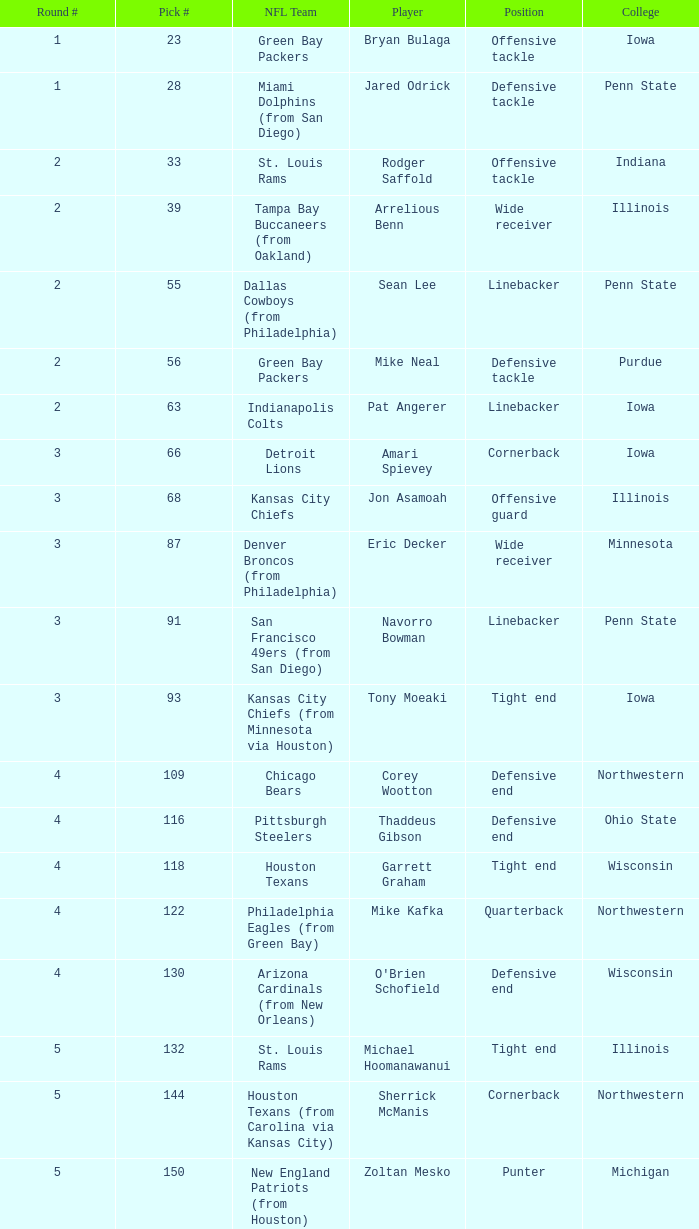What was sherrick mcmanis's initial round? 5.0. 